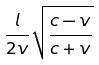<formula> <loc_0><loc_0><loc_500><loc_500>\frac { l } { 2 v } \sqrt { \frac { c - v } { c + v } }</formula> 